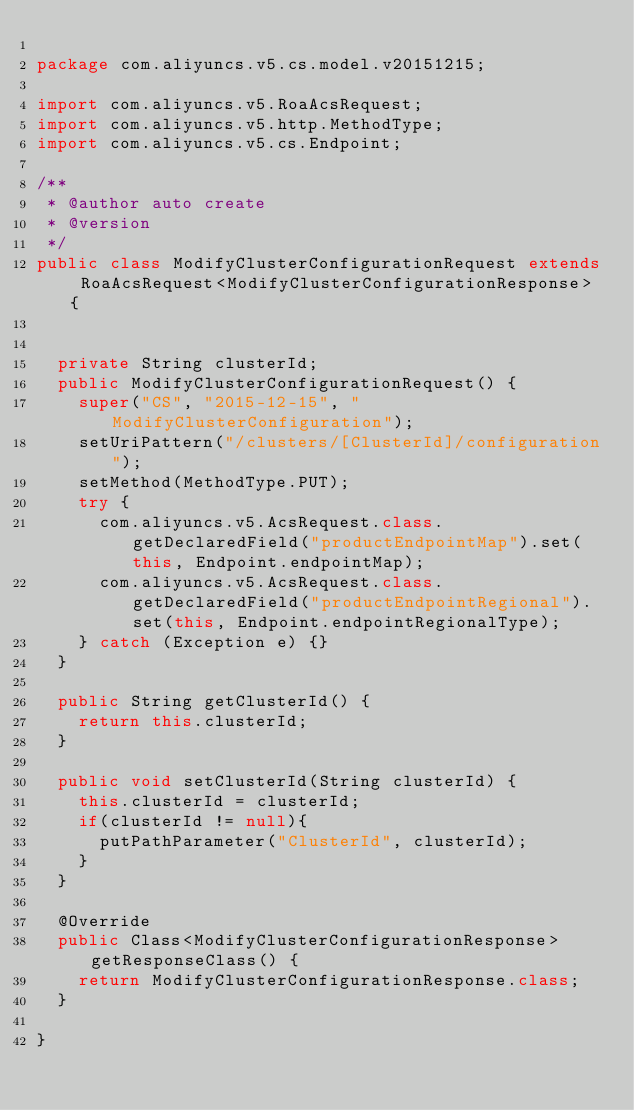Convert code to text. <code><loc_0><loc_0><loc_500><loc_500><_Java_>
package com.aliyuncs.v5.cs.model.v20151215;

import com.aliyuncs.v5.RoaAcsRequest;
import com.aliyuncs.v5.http.MethodType;
import com.aliyuncs.v5.cs.Endpoint;

/**
 * @author auto create
 * @version 
 */
public class ModifyClusterConfigurationRequest extends RoaAcsRequest<ModifyClusterConfigurationResponse> {
	   

	private String clusterId;
	public ModifyClusterConfigurationRequest() {
		super("CS", "2015-12-15", "ModifyClusterConfiguration");
		setUriPattern("/clusters/[ClusterId]/configuration");
		setMethod(MethodType.PUT);
		try {
			com.aliyuncs.v5.AcsRequest.class.getDeclaredField("productEndpointMap").set(this, Endpoint.endpointMap);
			com.aliyuncs.v5.AcsRequest.class.getDeclaredField("productEndpointRegional").set(this, Endpoint.endpointRegionalType);
		} catch (Exception e) {}
	}

	public String getClusterId() {
		return this.clusterId;
	}

	public void setClusterId(String clusterId) {
		this.clusterId = clusterId;
		if(clusterId != null){
			putPathParameter("ClusterId", clusterId);
		}
	}

	@Override
	public Class<ModifyClusterConfigurationResponse> getResponseClass() {
		return ModifyClusterConfigurationResponse.class;
	}

}
</code> 